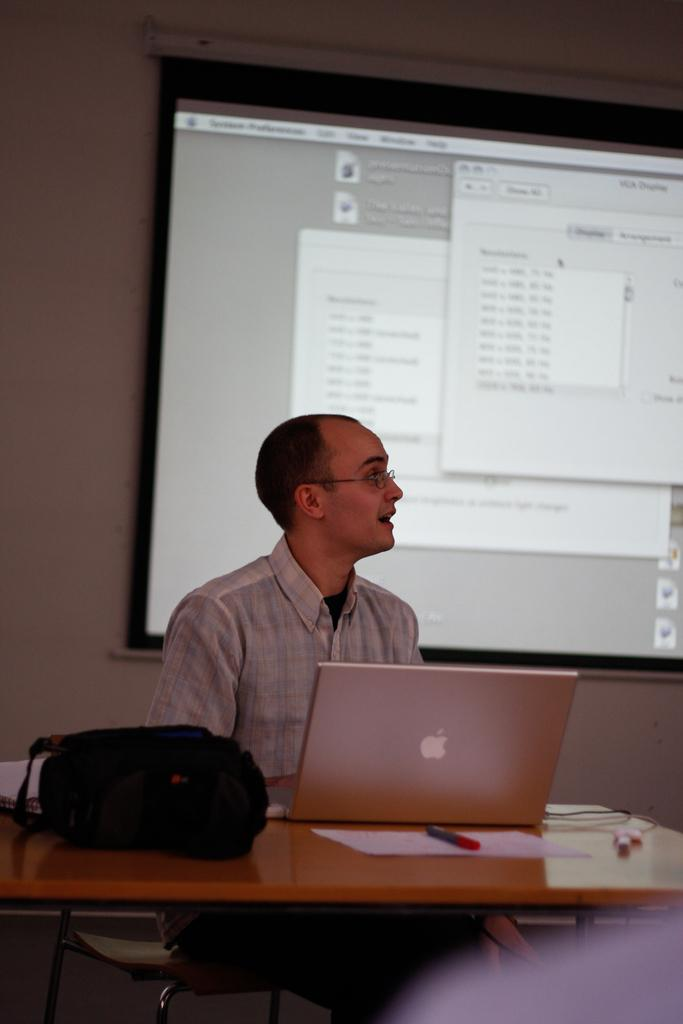What is the man in the image doing? The man is sitting in a chair. What object is on the table in front of the man? There is a laptop on the table. What else can be seen on the table? There is a bag, pens, and papers on the table. What is visible in the background of the image? There is a screen and a wall in the background. How does the man push the cable in the image? There is no cable present in the image, so it is not possible to answer that question. 